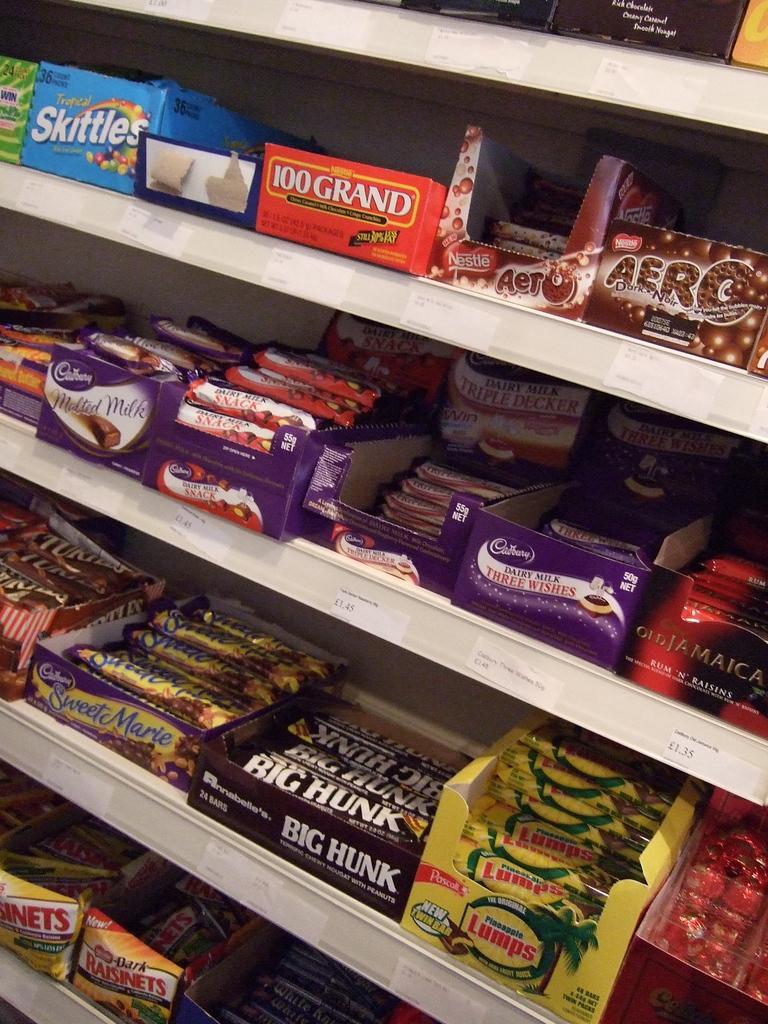Please provide a concise description of this image. In this image I can see few chocolates in the cardboard boxes and these are on the white color rack. 